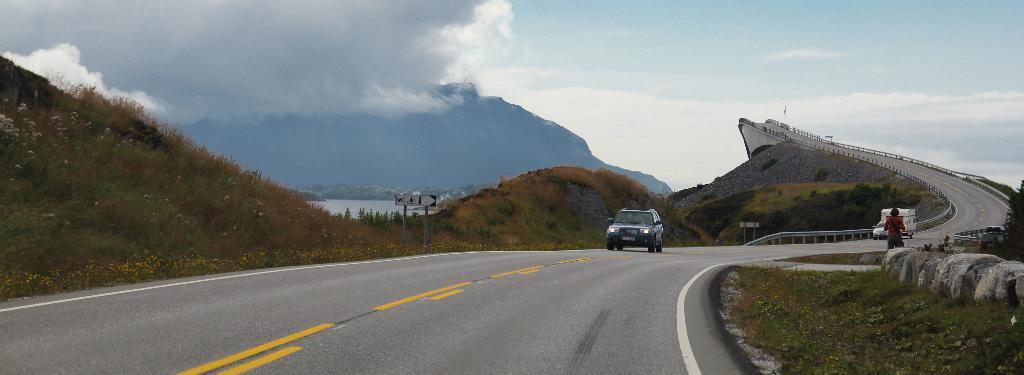Describe this image in one or two sentences. In this image there is a road, on which there are vehicles, persons, beside the road there are the hill, poles on which there is a board, at the top there is the sky and on the right side there are some stones. 